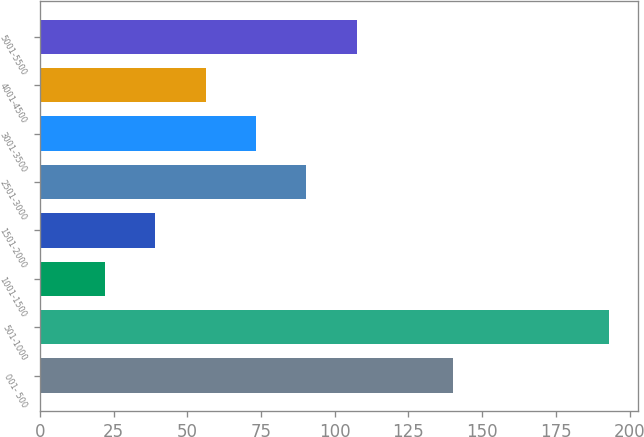Convert chart. <chart><loc_0><loc_0><loc_500><loc_500><bar_chart><fcel>001- 500<fcel>501-1000<fcel>1001-1500<fcel>1501-2000<fcel>2501-3000<fcel>3001-3500<fcel>4001-4500<fcel>5001-5500<nl><fcel>140<fcel>193<fcel>22<fcel>39.1<fcel>90.4<fcel>73.3<fcel>56.2<fcel>107.5<nl></chart> 